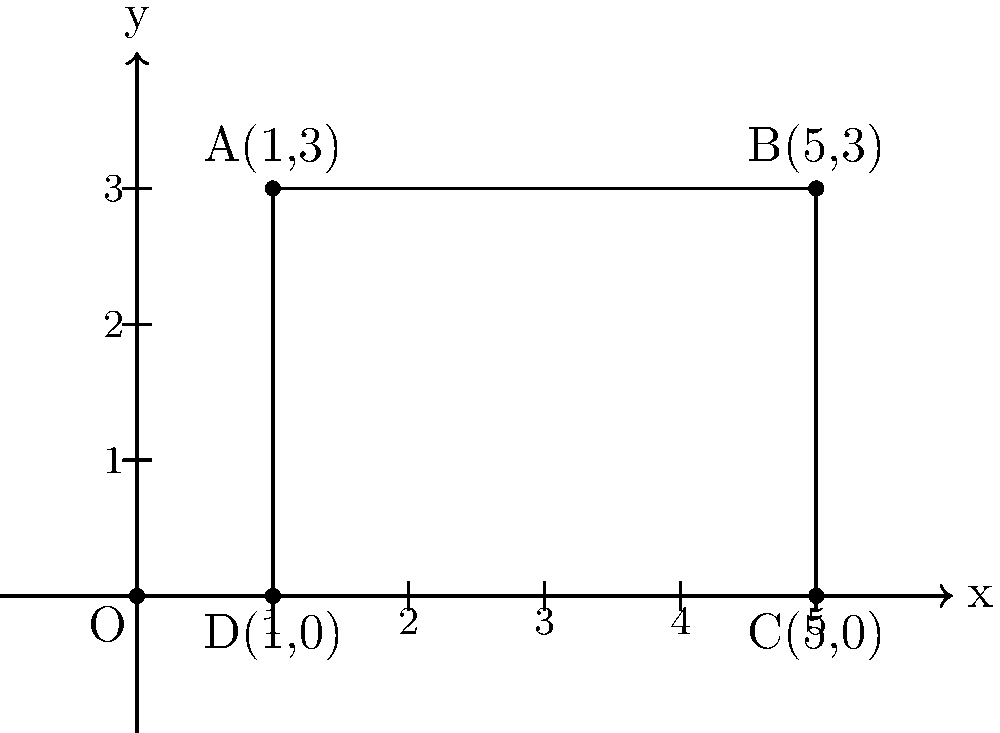In the spirit of Pulitzer Prize-winning authors who often use precise imagery in their work, consider a rectangle ABCD on a coordinate plane. The vertices of this rectangle are located at A(1,3), B(5,3), C(5,0), and D(1,0). Calculate the area of this rectangle, explaining your approach as if you were describing the process of crafting a vivid scene in a novel. To find the area of the rectangle, we'll follow these steps, much like crafting a scene in a novel:

1) First, we need to determine the length and width of the rectangle. This is similar to establishing the boundaries of our literary setting.

2) For the length (horizontal distance):
   - x-coordinate of B or C: 5
   - x-coordinate of A or D: 1
   - Length = $5 - 1 = 4$ units

3) For the width (vertical distance):
   - y-coordinate of A or B: 3
   - y-coordinate of C or D: 0
   - Width = $3 - 0 = 3$ units

4) Now, just as we would layer details to bring our scene to life, we'll use these dimensions to calculate the area:
   Area = length × width
   $$ \text{Area} = 4 \times 3 = 12 \text{ square units} $$

5) This process of calculating the area is analogous to how we might build up a scene in writing - starting with the basic framework (the coordinates) and then filling in the details (the calculations) to create a complete picture.
Answer: $12 \text{ square units}$ 